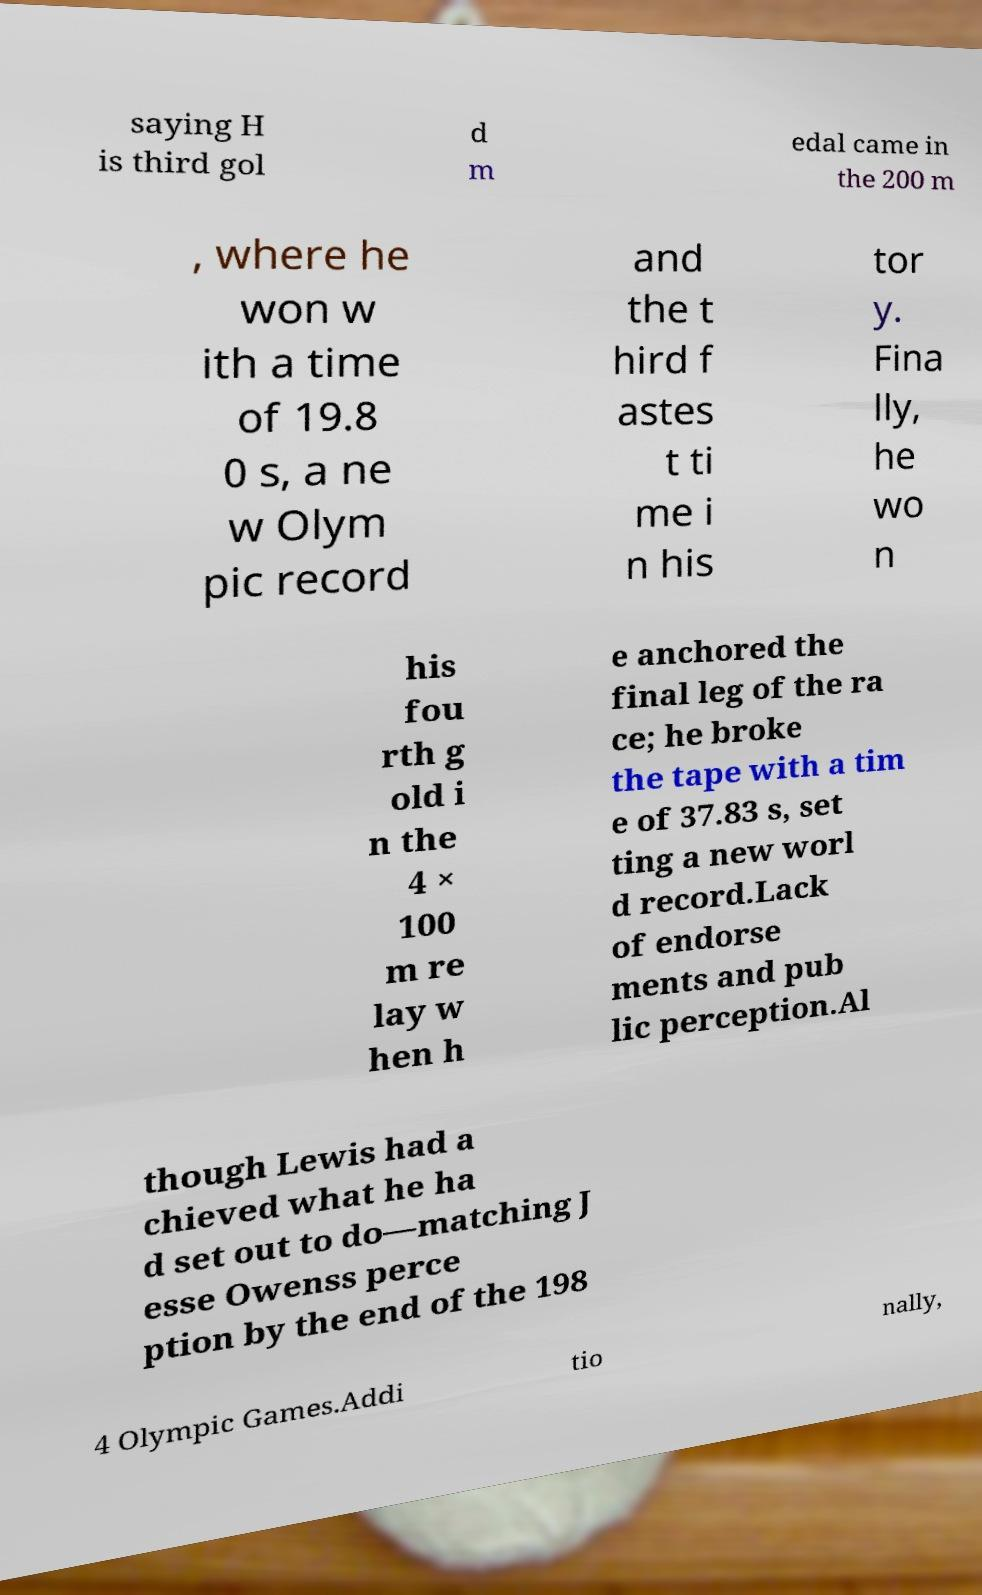I need the written content from this picture converted into text. Can you do that? saying H is third gol d m edal came in the 200 m , where he won w ith a time of 19.8 0 s, a ne w Olym pic record and the t hird f astes t ti me i n his tor y. Fina lly, he wo n his fou rth g old i n the 4 × 100 m re lay w hen h e anchored the final leg of the ra ce; he broke the tape with a tim e of 37.83 s, set ting a new worl d record.Lack of endorse ments and pub lic perception.Al though Lewis had a chieved what he ha d set out to do—matching J esse Owenss perce ption by the end of the 198 4 Olympic Games.Addi tio nally, 